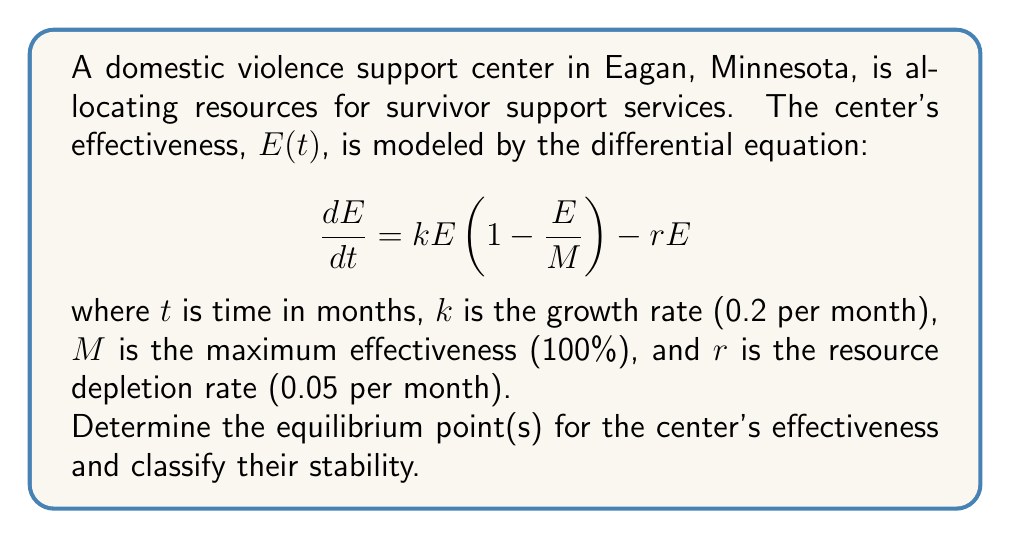Solve this math problem. Step 1: Find the equilibrium points by setting $\frac{dE}{dt} = 0$

$$0 = kE(1 - \frac{E}{M}) - rE$$

Step 2: Factor out E
$$0 = E(k(1 - \frac{E}{M}) - r)$$

Step 3: Solve for E
Either $E = 0$ or $k(1 - \frac{E}{M}) - r = 0$

For the second case:
$$k - \frac{kE}{M} - r = 0$$
$$k - r = \frac{kE}{M}$$
$$E = \frac{M(k-r)}{k} = 100 \cdot \frac{0.2 - 0.05}{0.2} = 75$$

So, the equilibrium points are $E = 0$ and $E = 75$.

Step 4: Determine stability by analyzing $\frac{d}{dE}(\frac{dE}{dt})$ at each equilibrium point

$$\frac{d}{dE}(\frac{dE}{dt}) = k - \frac{2kE}{M} - r$$

At $E = 0$: $k - r = 0.2 - 0.05 = 0.15 > 0$ (unstable)
At $E = 75$: $0.2 - \frac{2 \cdot 0.2 \cdot 75}{100} - 0.05 = -0.15 < 0$ (stable)
Answer: Equilibrium points: $E = 0$ (unstable) and $E = 75$ (stable) 